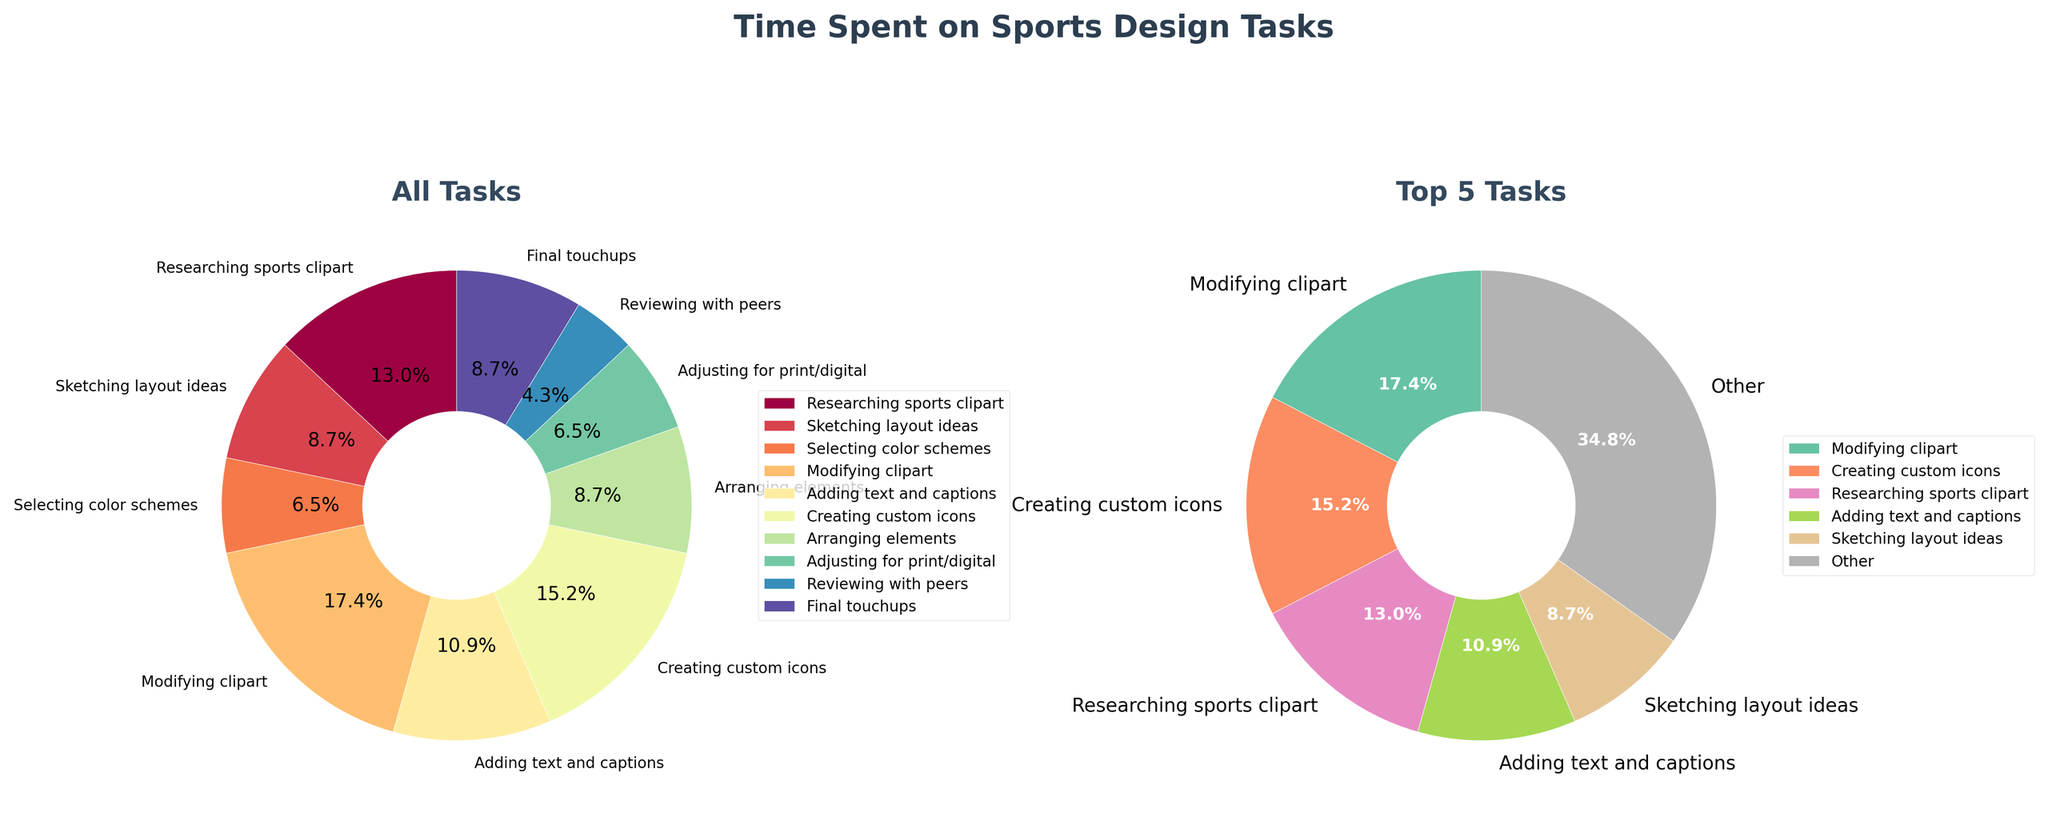Which task takes up the most time? Look at the wedges in the pie chart labeled 'All Tasks' and identify which task has the largest percentage or segment. 'Modifying clipart' is the task that takes up the most time with 4 hours.
Answer: Modifying clipart What is the title of the figure? The title of the figure is usually found at the very top of the visual and it's prominently displayed. In this case, it says 'Time Spent on Sports Design Tasks'.
Answer: Time Spent on Sports Design Tasks How many tasks are displayed in the 'Top 5 Tasks' pie chart? Count the labels in the pie chart on the right labeled 'Top 5 Tasks'. There are 6 slices because the last one is 'Other', which represents all remaining tasks.
Answer: 6 Which pie chart segment represents the smallest task in the 'All Tasks' pie chart? Look at the labels and their associated percentages in the 'All Tasks' pie chart and find the least percentage. 'Reviewing with peers', which is 1 hour, represents the smallest task.
Answer: Reviewing with peers Are there any tasks that take the same amount of time? From the data, compare the hours. 'Selecting color schemes' and 'Adjusting for print/digital' both take 1.5 hours. This is represented by identically sized wedges in the pie chart.
Answer: Yes How much time is spent on the top 5 tasks combined? Sum the hours for the top 5 tasks ('Modifying clipart', 'Creating custom icons', 'Researching sports clipart', 'Adding text and captions', 'Sketching layout ideas'). Then compare that sum to the total hours to find that the remaining hours are part of 'Other'. The hours add up to 15.5 hours.
Answer: 15.5 hours Which task occupies the largest segment in the 'Top 5 Tasks' pie chart? Observe the pie chart labeled 'Top 5 Tasks' and find the largest segment. It is 'Modifying clipart'.
Answer: Modifying clipart What's the total time spent on all design tasks combined? Sum all hours from each task: 3 + 2 + 1.5 + 4 + 2.5 + 3.5 + 2 + 1.5 + 1 + 2 = 23 hours. This can be verified by looking at the sum of all percentages equating to 100%.
Answer: 23 hours How does the segment size for 'Researching sports clipart' compare between the two pie charts? In the 'All Tasks' pie chart, 'Researching sports clipart' is displayed with a certain percentage. Compare this to its representation among top 5 tasks in the 'Top 5 Tasks' pie chart. Both charts should show relative size differences, but directly comparing the larger context of all tasks vs. just the top 5 provides insight. It appears larger in the latter as other tasks are grouped into 'Other'.
Answer: Larger in 'Top 5 Tasks' 